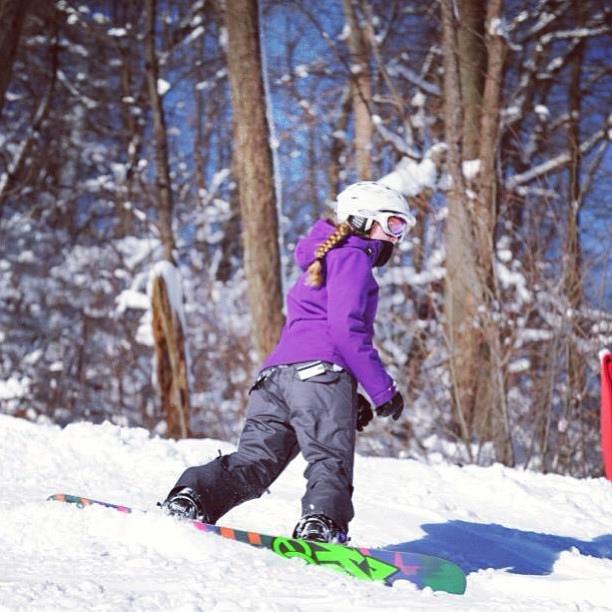Is this a girl skiing?
Quick response, please. No. What color is this person's jacket?
Concise answer only. Purple. Is the woman on a snowboard?
Short answer required. Yes. What's on the bench next to the man?
Give a very brief answer. No bench. Is this a women?
Keep it brief. No. 